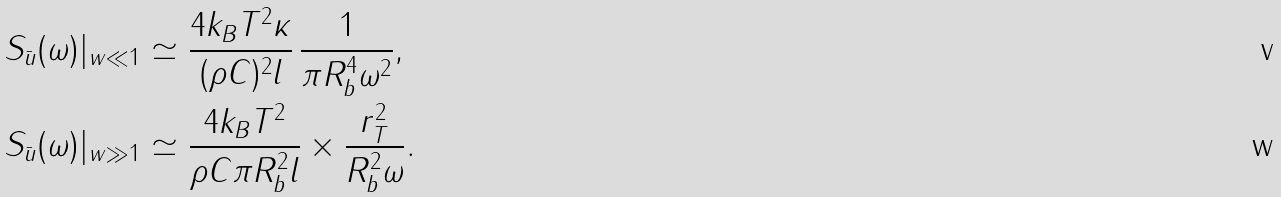Convert formula to latex. <formula><loc_0><loc_0><loc_500><loc_500>S _ { \bar { u } } ( \omega ) | _ { w \ll 1 } & \simeq \frac { 4 k _ { B } T ^ { 2 } \kappa } { ( \rho C ) ^ { 2 } l } \, \frac { 1 } { \pi R _ { b } ^ { 4 } \omega ^ { 2 } } , \\ S _ { \bar { u } } ( \omega ) | _ { w \gg 1 } & \simeq \frac { 4 k _ { B } T ^ { 2 } } { \rho C \pi R _ { b } ^ { 2 } l } \times \frac { r _ { T } ^ { 2 } } { R _ { b } ^ { 2 } \omega } .</formula> 